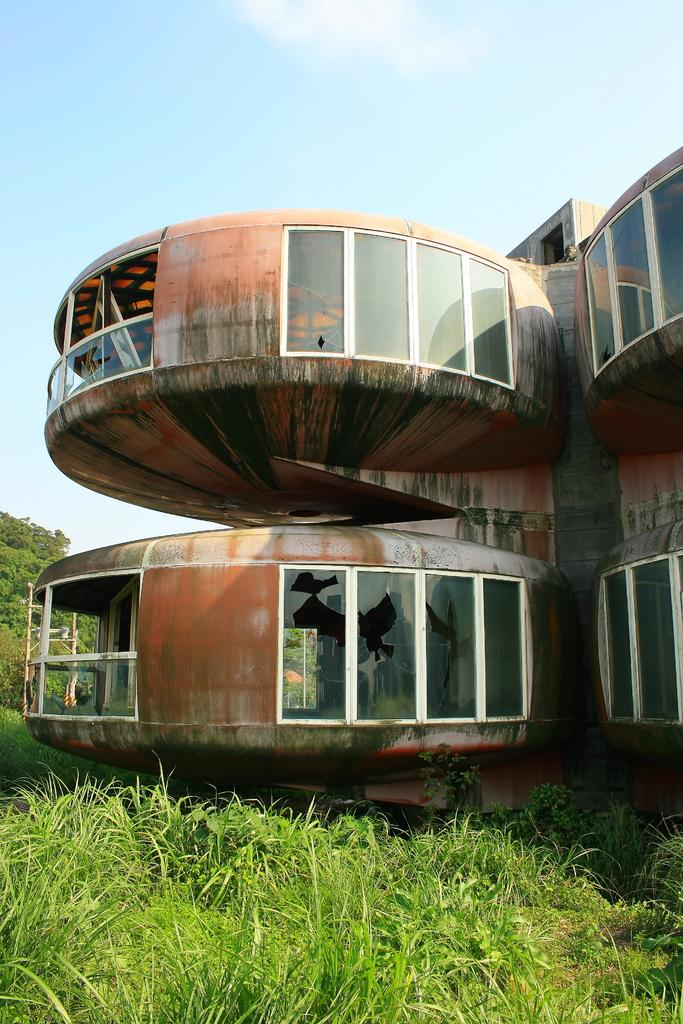What is the main structure in the center of the image? There is a building in the center of the image. What can be seen in the background of the image? There are trees in the background of the image. What type of vegetation covers the ground at the bottom of the image? The ground is covered with grass at the bottom of the image. How many sisters are present in the image? There are no sisters mentioned or depicted in the image. What type of shape is the building in the image? The provided facts do not mention the shape of the building, so we cannot determine its shape from the information given. 